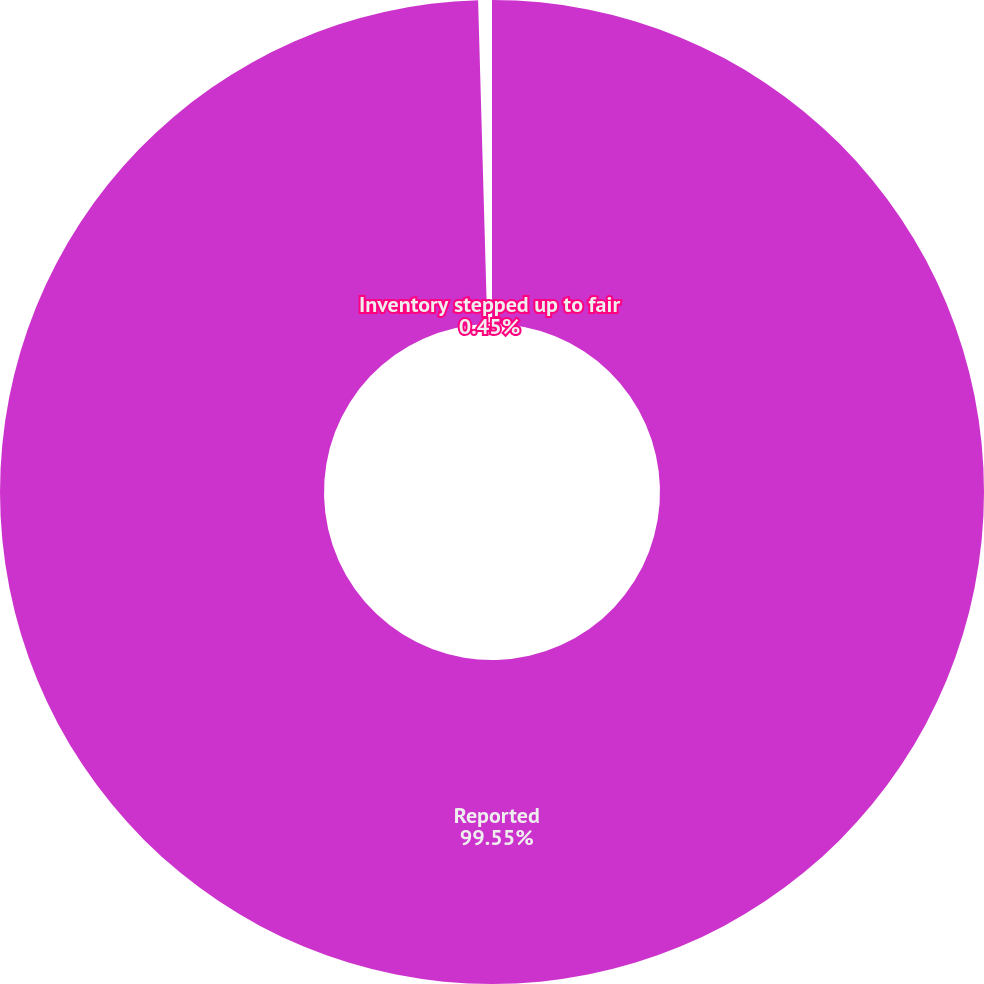Convert chart to OTSL. <chart><loc_0><loc_0><loc_500><loc_500><pie_chart><fcel>Reported<fcel>Inventory stepped up to fair<nl><fcel>99.55%<fcel>0.45%<nl></chart> 